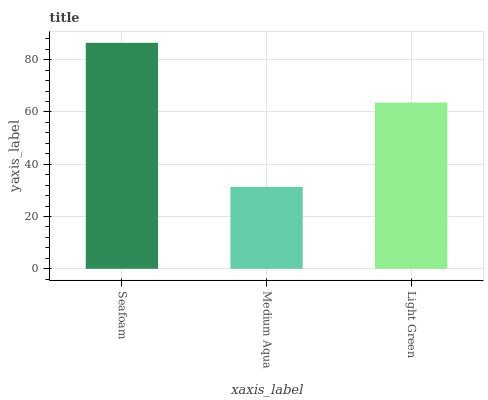Is Light Green the minimum?
Answer yes or no. No. Is Light Green the maximum?
Answer yes or no. No. Is Light Green greater than Medium Aqua?
Answer yes or no. Yes. Is Medium Aqua less than Light Green?
Answer yes or no. Yes. Is Medium Aqua greater than Light Green?
Answer yes or no. No. Is Light Green less than Medium Aqua?
Answer yes or no. No. Is Light Green the high median?
Answer yes or no. Yes. Is Light Green the low median?
Answer yes or no. Yes. Is Medium Aqua the high median?
Answer yes or no. No. Is Medium Aqua the low median?
Answer yes or no. No. 